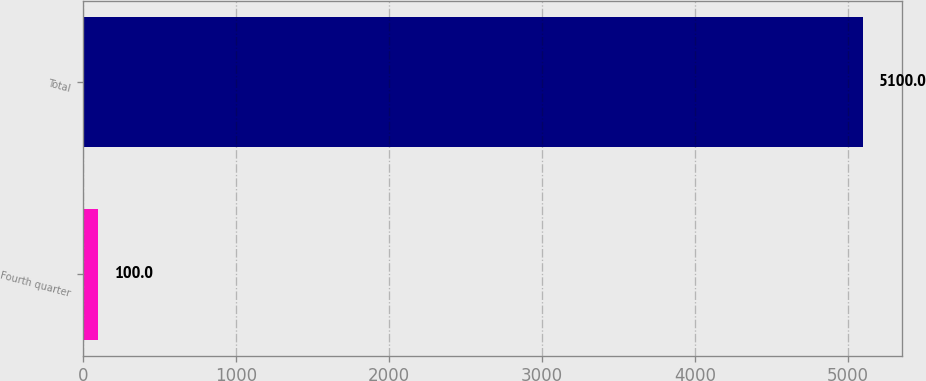Convert chart to OTSL. <chart><loc_0><loc_0><loc_500><loc_500><bar_chart><fcel>Fourth quarter<fcel>Total<nl><fcel>100<fcel>5100<nl></chart> 